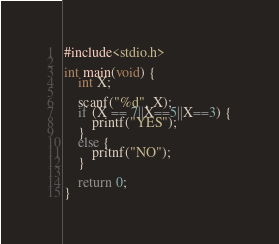Convert code to text. <code><loc_0><loc_0><loc_500><loc_500><_C_>#include<stdio.h>

int main(void) {
	int X;

	scanf("%d", X);
	if (X == 7||X==5||X==3) {
		printf("YES");
	}
	else {
		pritnf("NO");
	}

	return 0;
}</code> 